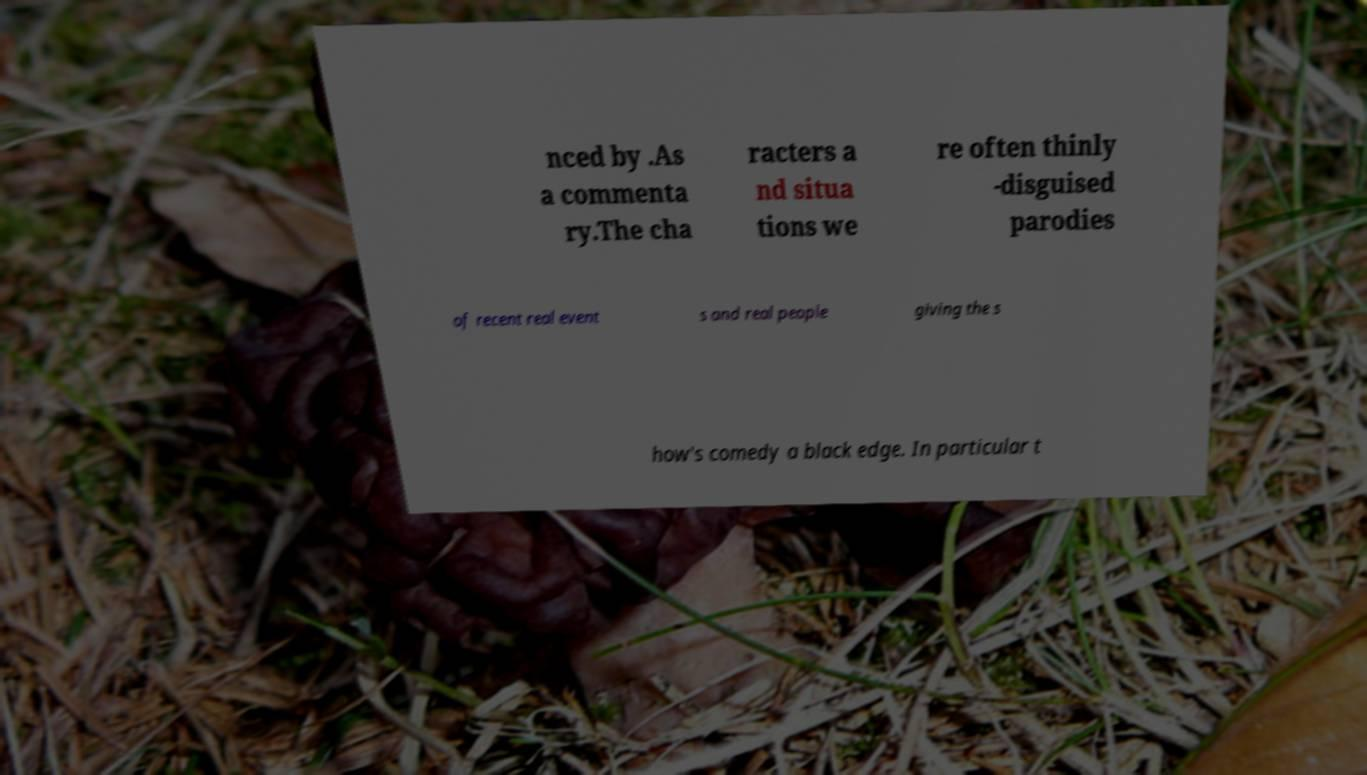Can you read and provide the text displayed in the image?This photo seems to have some interesting text. Can you extract and type it out for me? nced by .As a commenta ry.The cha racters a nd situa tions we re often thinly -disguised parodies of recent real event s and real people giving the s how's comedy a black edge. In particular t 